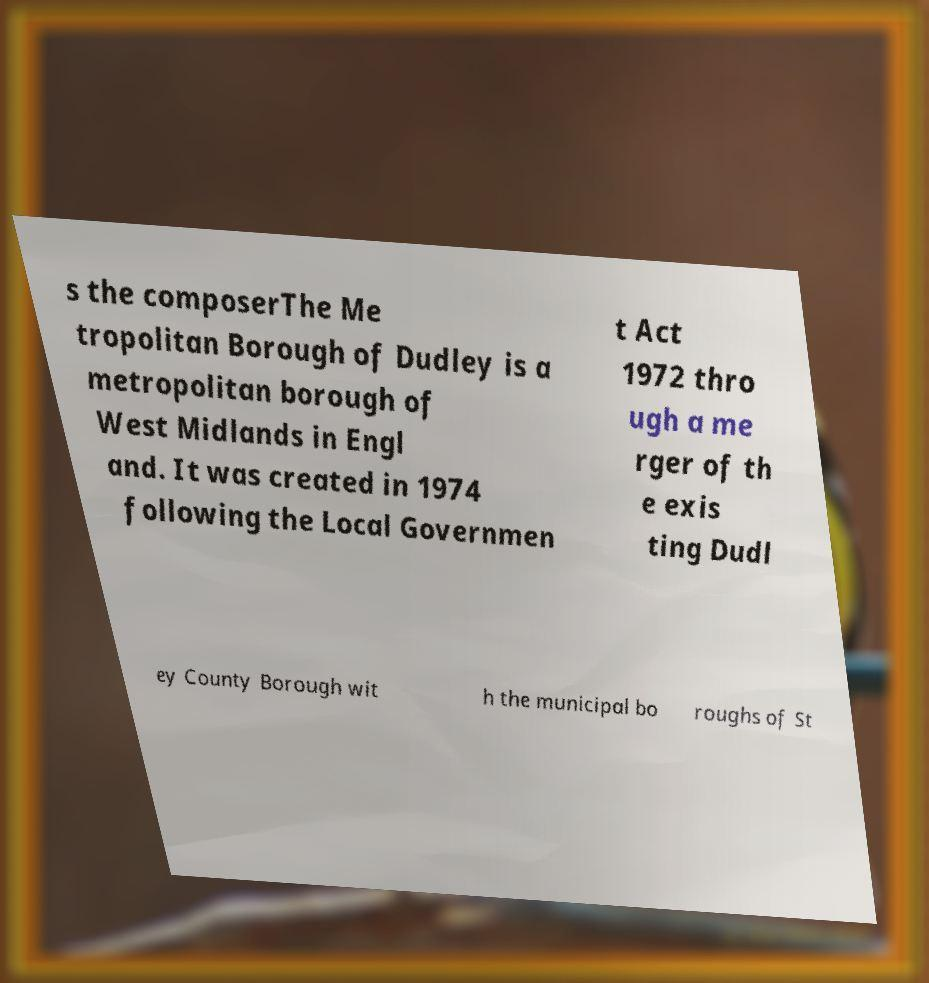For documentation purposes, I need the text within this image transcribed. Could you provide that? s the composerThe Me tropolitan Borough of Dudley is a metropolitan borough of West Midlands in Engl and. It was created in 1974 following the Local Governmen t Act 1972 thro ugh a me rger of th e exis ting Dudl ey County Borough wit h the municipal bo roughs of St 